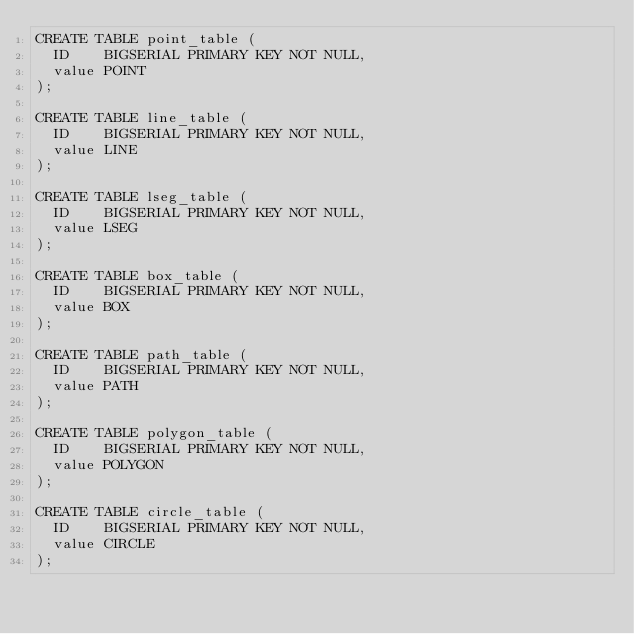<code> <loc_0><loc_0><loc_500><loc_500><_SQL_>CREATE TABLE point_table (
  ID    BIGSERIAL PRIMARY KEY NOT NULL,
  value POINT
);

CREATE TABLE line_table (
  ID    BIGSERIAL PRIMARY KEY NOT NULL,
  value LINE
);

CREATE TABLE lseg_table (
  ID    BIGSERIAL PRIMARY KEY NOT NULL,
  value LSEG
);

CREATE TABLE box_table (
  ID    BIGSERIAL PRIMARY KEY NOT NULL,
  value BOX
);

CREATE TABLE path_table (
  ID    BIGSERIAL PRIMARY KEY NOT NULL,
  value PATH
);

CREATE TABLE polygon_table (
  ID    BIGSERIAL PRIMARY KEY NOT NULL,
  value POLYGON
);

CREATE TABLE circle_table (
  ID    BIGSERIAL PRIMARY KEY NOT NULL,
  value CIRCLE
);</code> 